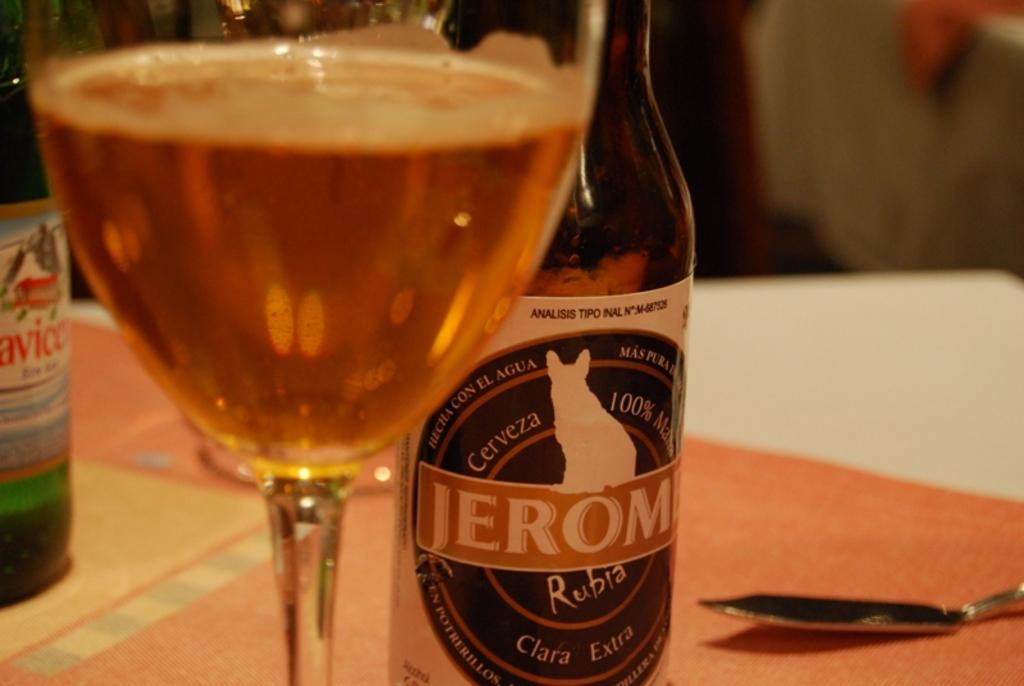<image>
Create a compact narrative representing the image presented. Glass for of beer sits next to a bottle of Clara Extra. 